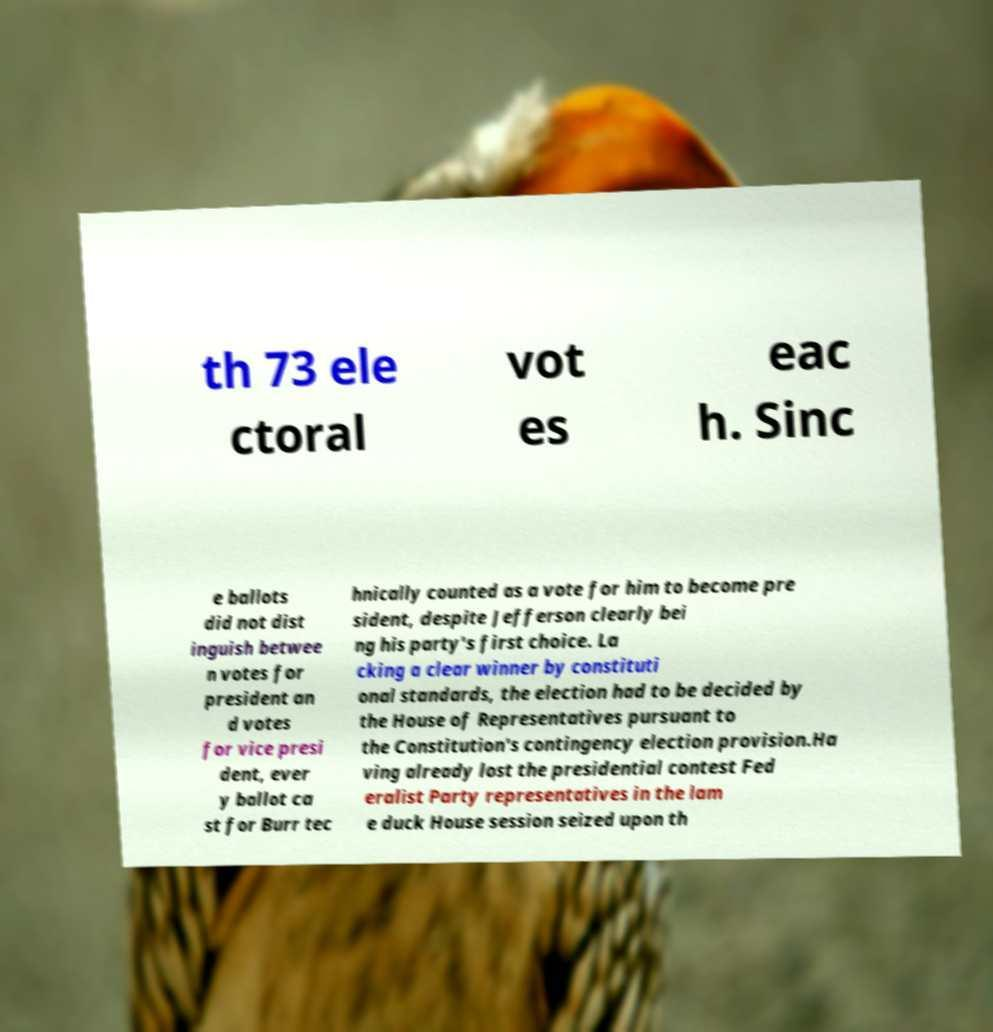Could you extract and type out the text from this image? th 73 ele ctoral vot es eac h. Sinc e ballots did not dist inguish betwee n votes for president an d votes for vice presi dent, ever y ballot ca st for Burr tec hnically counted as a vote for him to become pre sident, despite Jefferson clearly bei ng his party's first choice. La cking a clear winner by constituti onal standards, the election had to be decided by the House of Representatives pursuant to the Constitution's contingency election provision.Ha ving already lost the presidential contest Fed eralist Party representatives in the lam e duck House session seized upon th 